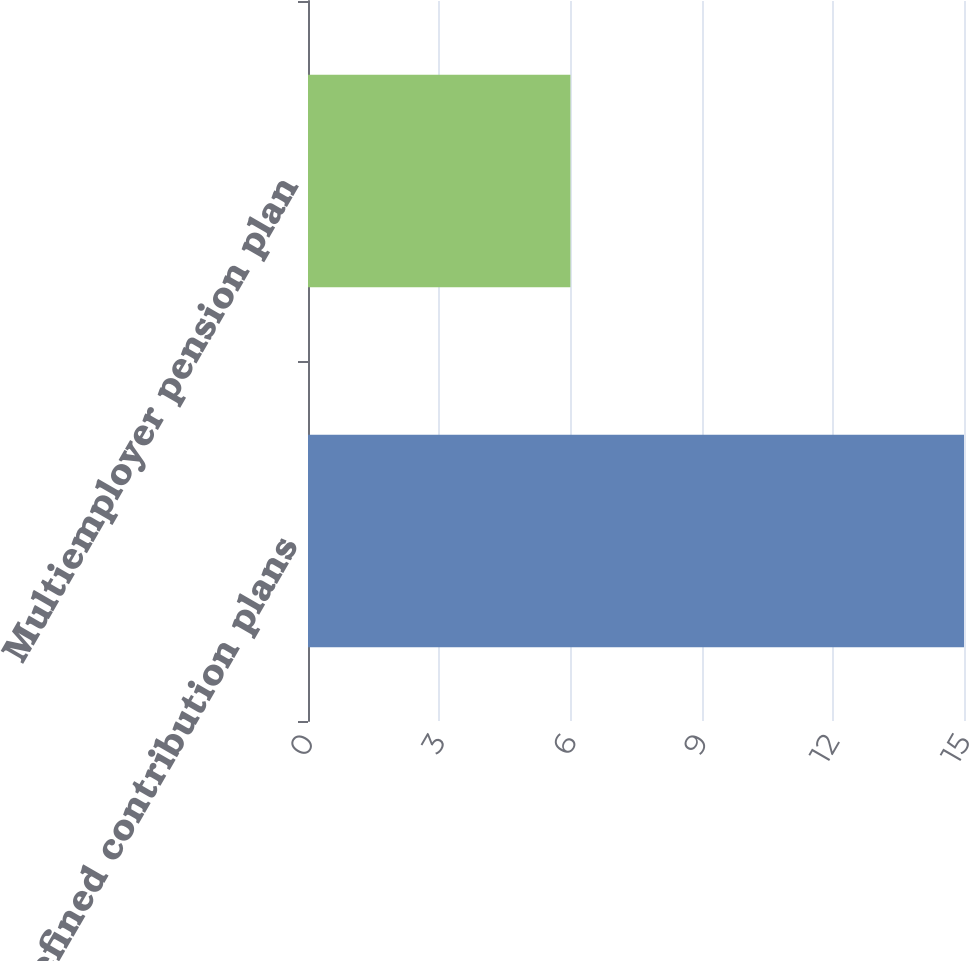Convert chart. <chart><loc_0><loc_0><loc_500><loc_500><bar_chart><fcel>Defined contribution plans<fcel>Multiemployer pension plan<nl><fcel>15<fcel>6<nl></chart> 